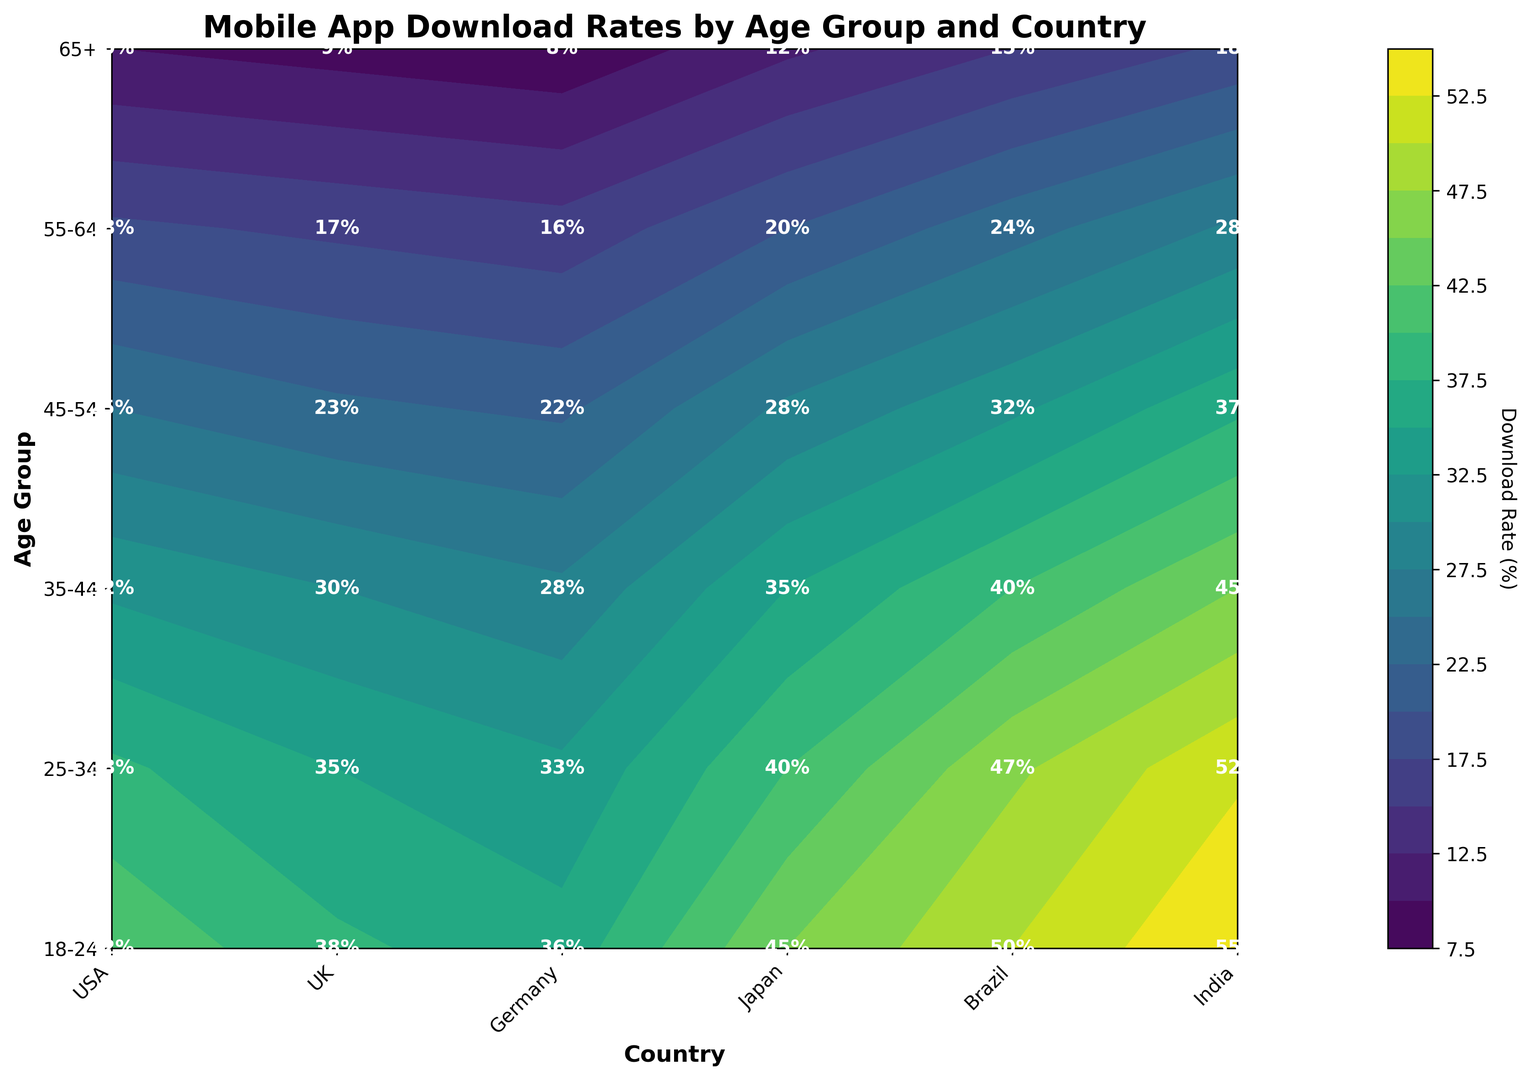What age group in India has the highest download rate? To find the age group with the highest download rate in India, look at the download rates across all age groups for India. The highest value is 55% for the 18-24 age group.
Answer: 18-24 How does the download rate for 25-34-year-olds in Brazil compare to that of the 35-44-year-olds in Japan? Check the download rate for 25-34-year-olds in Brazil (47%) and compare it with the download rate for 35-44-year-olds in Japan (35%).
Answer: Higher What is the difference in download rates between the youngest and oldest age groups in the USA? Compare the download rates for the 18-24 age group (42%) and 65+ age group (10%) in the USA, then subtract the latter from the former: 42% - 10% = 32%.
Answer: 32% Which country's 45-54 age group has the second-highest download rate, and what is this rate? Check the download rates for the 45-54 age group across all countries. India has the highest (37%), and Brazil has the second-highest (32%).
Answer: Brazil, 32% What is the average download rate for the 35-44 age group across all countries? Sum the download rates for the 35-44 age group across all countries (32%+30%+28%+35%+40%+45%=210%), then divide by the number of countries (6): 210% / 6 = 35%.
Answer: 35% Which country has the most visually noticeable color difference between the 18-24 and 65+ age groups? Look for the most distinct color contrast between the youngest (18-24) and oldest (65+) age groups in the contour. India and Brazil have the most noticeable differences due to higher download rates in the younger and much lower rates in the oldest groups. Therefore, India has the highest range of download rates from 55% to 18%.
Answer: India What is the total download rate for all age groups combined in Japan? Sum the download rates for all age groups in Japan: 
45% + 40% + 35% + 28% + 20% + 12% = 180%.
Answer: 180% 